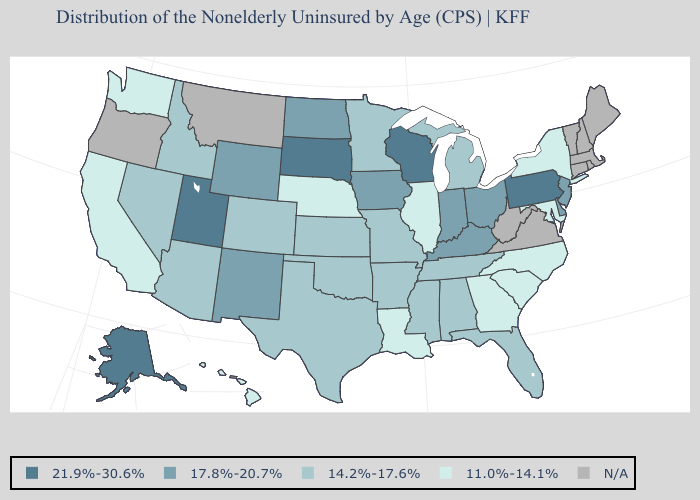Does Utah have the highest value in the West?
Concise answer only. Yes. Name the states that have a value in the range N/A?
Keep it brief. Connecticut, Maine, Massachusetts, Montana, New Hampshire, Oregon, Rhode Island, Vermont, Virginia, West Virginia. Is the legend a continuous bar?
Write a very short answer. No. Name the states that have a value in the range N/A?
Be succinct. Connecticut, Maine, Massachusetts, Montana, New Hampshire, Oregon, Rhode Island, Vermont, Virginia, West Virginia. What is the value of Alabama?
Quick response, please. 14.2%-17.6%. Does South Dakota have the highest value in the USA?
Short answer required. Yes. Among the states that border Texas , does Louisiana have the highest value?
Concise answer only. No. Name the states that have a value in the range 14.2%-17.6%?
Quick response, please. Alabama, Arizona, Arkansas, Colorado, Florida, Idaho, Kansas, Michigan, Minnesota, Mississippi, Missouri, Nevada, Oklahoma, Tennessee, Texas. What is the lowest value in the USA?
Give a very brief answer. 11.0%-14.1%. Name the states that have a value in the range 11.0%-14.1%?
Give a very brief answer. California, Georgia, Hawaii, Illinois, Louisiana, Maryland, Nebraska, New York, North Carolina, South Carolina, Washington. What is the highest value in the USA?
Answer briefly. 21.9%-30.6%. What is the value of Arkansas?
Write a very short answer. 14.2%-17.6%. What is the value of Kentucky?
Short answer required. 17.8%-20.7%. What is the lowest value in the Northeast?
Write a very short answer. 11.0%-14.1%. Does Nebraska have the lowest value in the MidWest?
Keep it brief. Yes. 